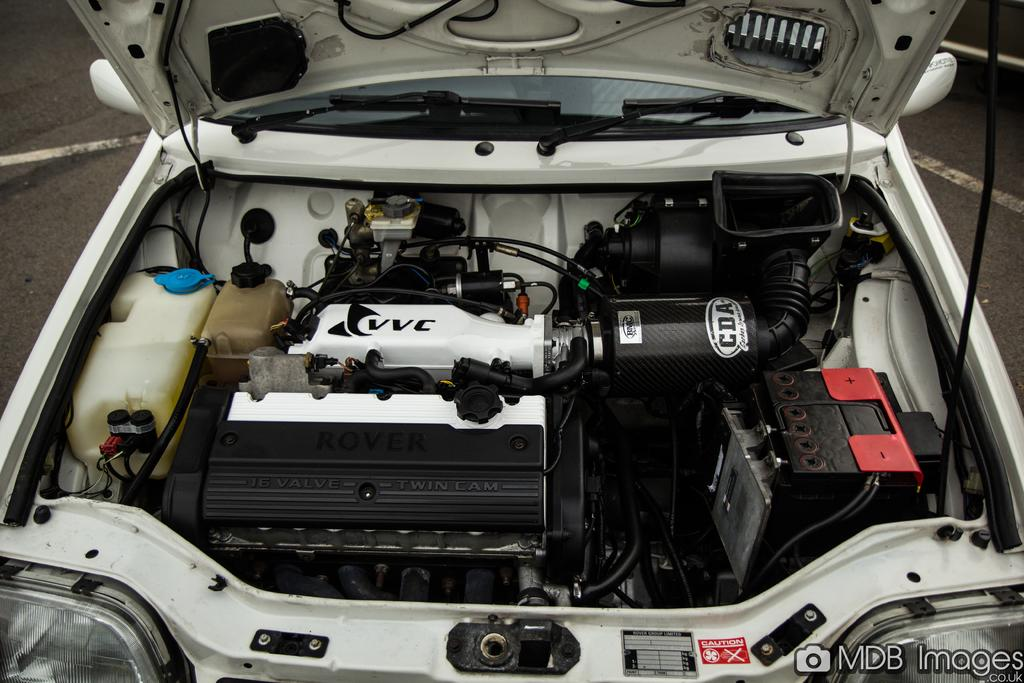What is the position of the car bonnet in the image? The car bonnet is opened in the image. Is there any text present in the image? Yes, there is text at the bottom right corner of the image. What part of the car can be seen when the bonnet is opened? The engine of the car is visible in the image. What type of rake is being used to clean the engine in the image? There is no rake present in the image, and the engine is not being cleaned in the image. 